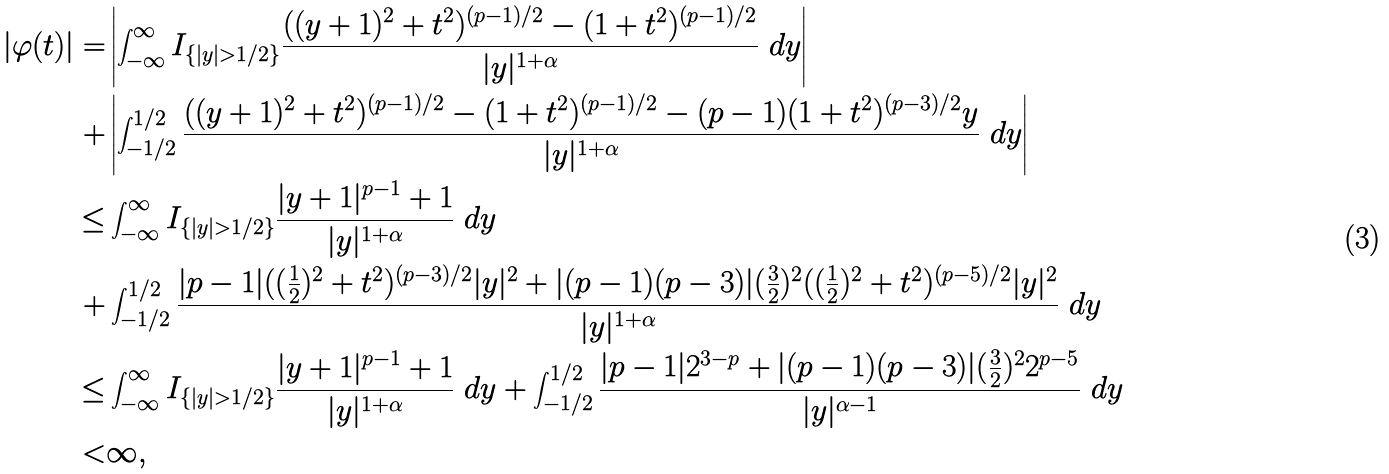<formula> <loc_0><loc_0><loc_500><loc_500>| \varphi ( t ) | = & \left | \int _ { - \infty } ^ { \infty } I _ { \{ | y | > 1 / 2 \} } \frac { ( ( y + 1 ) ^ { 2 } + t ^ { 2 } ) ^ { ( p - 1 ) / 2 } - ( 1 + t ^ { 2 } ) ^ { ( p - 1 ) / 2 } } { | y | ^ { 1 + \alpha } } \ d y \right | \\ + & \left | \int _ { - 1 / 2 } ^ { 1 / 2 } \frac { ( ( y + 1 ) ^ { 2 } + t ^ { 2 } ) ^ { ( p - 1 ) / 2 } - ( 1 + t ^ { 2 } ) ^ { ( p - 1 ) / 2 } - ( p - 1 ) ( 1 + t ^ { 2 } ) ^ { ( p - 3 ) / 2 } y } { | y | ^ { 1 + \alpha } } \ d y \right | \\ \leq & \int _ { - \infty } ^ { \infty } I _ { \{ | y | > 1 / 2 \} } \frac { | y + 1 | ^ { p - 1 } + 1 } { | y | ^ { 1 + \alpha } } \ d y \\ + & \int _ { - 1 / 2 } ^ { 1 / 2 } \frac { | p - 1 | ( ( \frac { 1 } { 2 } ) ^ { 2 } + t ^ { 2 } ) ^ { ( p - 3 ) / 2 } | y | ^ { 2 } + | ( p - 1 ) ( p - 3 ) | ( \frac { 3 } { 2 } ) ^ { 2 } ( ( \frac { 1 } { 2 } ) ^ { 2 } + t ^ { 2 } ) ^ { ( p - 5 ) / 2 } | y | ^ { 2 } } { | y | ^ { 1 + \alpha } } \ d y \\ \leq & \int _ { - \infty } ^ { \infty } I _ { \{ | y | > 1 / 2 \} } \frac { | y + 1 | ^ { p - 1 } + 1 } { | y | ^ { 1 + \alpha } } \ d y + \int _ { - 1 / 2 } ^ { 1 / 2 } \frac { | p - 1 | 2 ^ { 3 - p } + | ( p - 1 ) ( p - 3 ) | ( \frac { 3 } { 2 } ) ^ { 2 } 2 ^ { p - 5 } } { | y | ^ { \alpha - 1 } } \ d y \\ < & \infty ,</formula> 